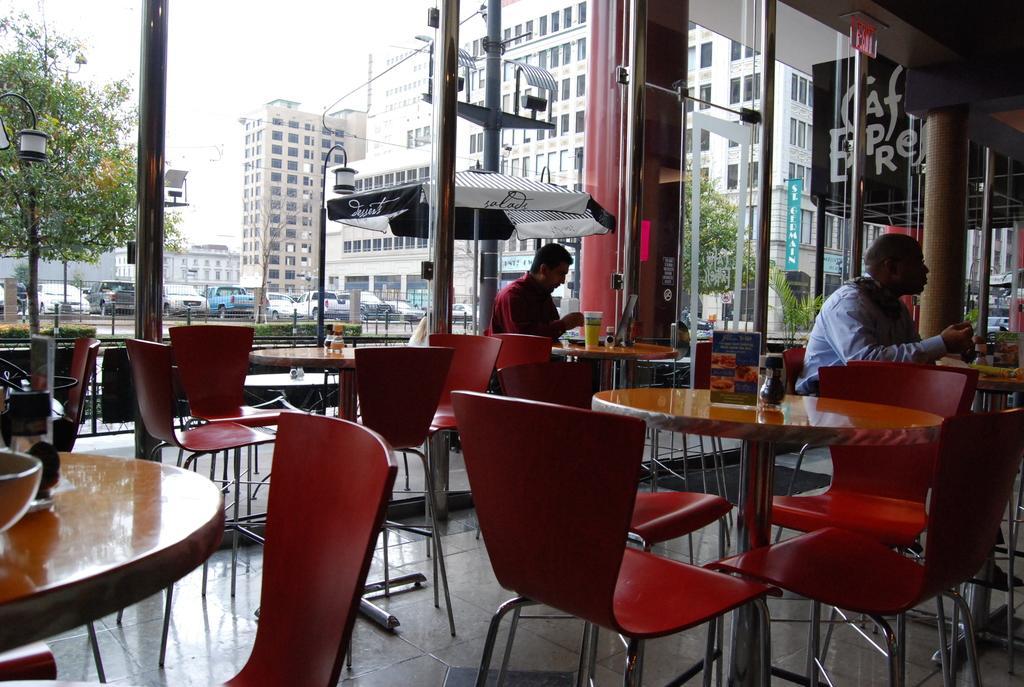Please provide a concise description of this image. In this picture we can see inside view of the restaurant. In the front we can see some round tables and red chairs. Behind there are two men sitting and drinking the tea. In the background we can see glass wall and some buildings and trees are seen. 